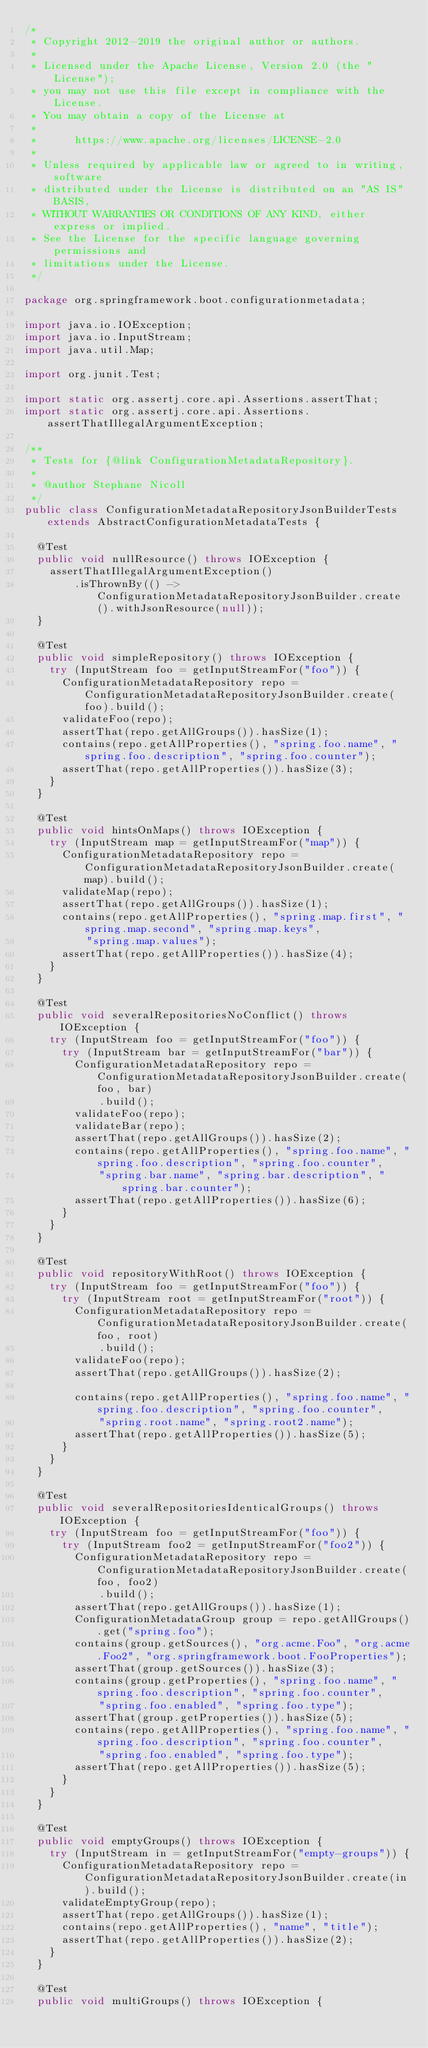Convert code to text. <code><loc_0><loc_0><loc_500><loc_500><_Java_>/*
 * Copyright 2012-2019 the original author or authors.
 *
 * Licensed under the Apache License, Version 2.0 (the "License");
 * you may not use this file except in compliance with the License.
 * You may obtain a copy of the License at
 *
 *      https://www.apache.org/licenses/LICENSE-2.0
 *
 * Unless required by applicable law or agreed to in writing, software
 * distributed under the License is distributed on an "AS IS" BASIS,
 * WITHOUT WARRANTIES OR CONDITIONS OF ANY KIND, either express or implied.
 * See the License for the specific language governing permissions and
 * limitations under the License.
 */

package org.springframework.boot.configurationmetadata;

import java.io.IOException;
import java.io.InputStream;
import java.util.Map;

import org.junit.Test;

import static org.assertj.core.api.Assertions.assertThat;
import static org.assertj.core.api.Assertions.assertThatIllegalArgumentException;

/**
 * Tests for {@link ConfigurationMetadataRepository}.
 *
 * @author Stephane Nicoll
 */
public class ConfigurationMetadataRepositoryJsonBuilderTests extends AbstractConfigurationMetadataTests {

	@Test
	public void nullResource() throws IOException {
		assertThatIllegalArgumentException()
				.isThrownBy(() -> ConfigurationMetadataRepositoryJsonBuilder.create().withJsonResource(null));
	}

	@Test
	public void simpleRepository() throws IOException {
		try (InputStream foo = getInputStreamFor("foo")) {
			ConfigurationMetadataRepository repo = ConfigurationMetadataRepositoryJsonBuilder.create(foo).build();
			validateFoo(repo);
			assertThat(repo.getAllGroups()).hasSize(1);
			contains(repo.getAllProperties(), "spring.foo.name", "spring.foo.description", "spring.foo.counter");
			assertThat(repo.getAllProperties()).hasSize(3);
		}
	}

	@Test
	public void hintsOnMaps() throws IOException {
		try (InputStream map = getInputStreamFor("map")) {
			ConfigurationMetadataRepository repo = ConfigurationMetadataRepositoryJsonBuilder.create(map).build();
			validateMap(repo);
			assertThat(repo.getAllGroups()).hasSize(1);
			contains(repo.getAllProperties(), "spring.map.first", "spring.map.second", "spring.map.keys",
					"spring.map.values");
			assertThat(repo.getAllProperties()).hasSize(4);
		}
	}

	@Test
	public void severalRepositoriesNoConflict() throws IOException {
		try (InputStream foo = getInputStreamFor("foo")) {
			try (InputStream bar = getInputStreamFor("bar")) {
				ConfigurationMetadataRepository repo = ConfigurationMetadataRepositoryJsonBuilder.create(foo, bar)
						.build();
				validateFoo(repo);
				validateBar(repo);
				assertThat(repo.getAllGroups()).hasSize(2);
				contains(repo.getAllProperties(), "spring.foo.name", "spring.foo.description", "spring.foo.counter",
						"spring.bar.name", "spring.bar.description", "spring.bar.counter");
				assertThat(repo.getAllProperties()).hasSize(6);
			}
		}
	}

	@Test
	public void repositoryWithRoot() throws IOException {
		try (InputStream foo = getInputStreamFor("foo")) {
			try (InputStream root = getInputStreamFor("root")) {
				ConfigurationMetadataRepository repo = ConfigurationMetadataRepositoryJsonBuilder.create(foo, root)
						.build();
				validateFoo(repo);
				assertThat(repo.getAllGroups()).hasSize(2);

				contains(repo.getAllProperties(), "spring.foo.name", "spring.foo.description", "spring.foo.counter",
						"spring.root.name", "spring.root2.name");
				assertThat(repo.getAllProperties()).hasSize(5);
			}
		}
	}

	@Test
	public void severalRepositoriesIdenticalGroups() throws IOException {
		try (InputStream foo = getInputStreamFor("foo")) {
			try (InputStream foo2 = getInputStreamFor("foo2")) {
				ConfigurationMetadataRepository repo = ConfigurationMetadataRepositoryJsonBuilder.create(foo, foo2)
						.build();
				assertThat(repo.getAllGroups()).hasSize(1);
				ConfigurationMetadataGroup group = repo.getAllGroups().get("spring.foo");
				contains(group.getSources(), "org.acme.Foo", "org.acme.Foo2", "org.springframework.boot.FooProperties");
				assertThat(group.getSources()).hasSize(3);
				contains(group.getProperties(), "spring.foo.name", "spring.foo.description", "spring.foo.counter",
						"spring.foo.enabled", "spring.foo.type");
				assertThat(group.getProperties()).hasSize(5);
				contains(repo.getAllProperties(), "spring.foo.name", "spring.foo.description", "spring.foo.counter",
						"spring.foo.enabled", "spring.foo.type");
				assertThat(repo.getAllProperties()).hasSize(5);
			}
		}
	}

	@Test
	public void emptyGroups() throws IOException {
		try (InputStream in = getInputStreamFor("empty-groups")) {
			ConfigurationMetadataRepository repo = ConfigurationMetadataRepositoryJsonBuilder.create(in).build();
			validateEmptyGroup(repo);
			assertThat(repo.getAllGroups()).hasSize(1);
			contains(repo.getAllProperties(), "name", "title");
			assertThat(repo.getAllProperties()).hasSize(2);
		}
	}

	@Test
	public void multiGroups() throws IOException {</code> 